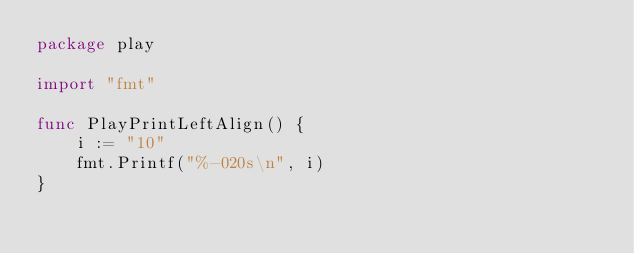Convert code to text. <code><loc_0><loc_0><loc_500><loc_500><_Go_>package play

import "fmt"

func PlayPrintLeftAlign() {
	i := "10"
	fmt.Printf("%-020s\n", i)
}
</code> 